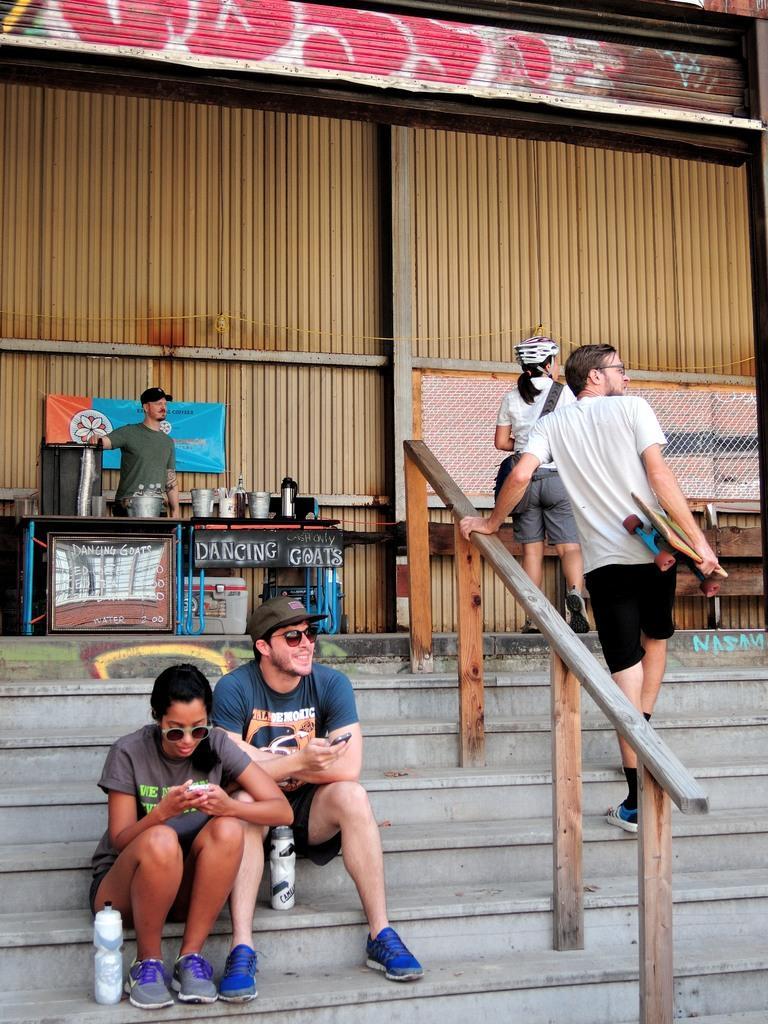In one or two sentences, can you explain what this image depicts? The boy in blue T-shirt and the woman in brown T-shirt are sitting on the staircase. Beside them, we see two water bottles. Both of them are holding the mobile phones in their hands. Beside them, we see two people walking. Behind them, we see a man in green T-shirt is standing. In front of him, we see a table on which vessels, jars and flask are placed. Behind him, we see a building in brown color. 